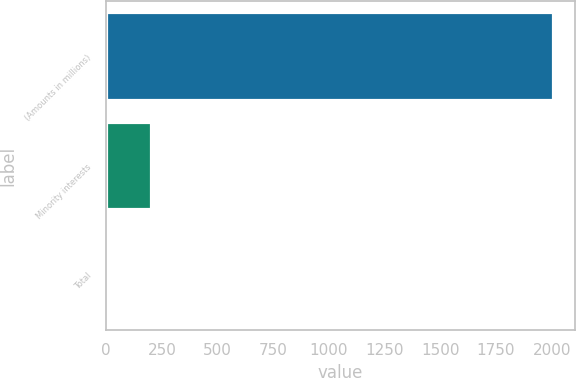<chart> <loc_0><loc_0><loc_500><loc_500><bar_chart><fcel>(Amounts in millions)<fcel>Minority interests<fcel>Total<nl><fcel>2005<fcel>201.76<fcel>1.4<nl></chart> 